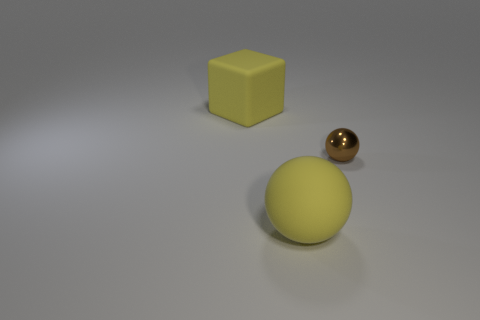Add 1 large brown cylinders. How many objects exist? 4 Subtract all brown spheres. How many spheres are left? 1 Subtract all spheres. How many objects are left? 1 Subtract all brown balls. Subtract all yellow cylinders. How many balls are left? 1 Subtract all yellow blocks. How many yellow balls are left? 1 Subtract all rubber objects. Subtract all small metallic balls. How many objects are left? 0 Add 2 big balls. How many big balls are left? 3 Add 3 tiny purple shiny cubes. How many tiny purple shiny cubes exist? 3 Subtract 0 purple cubes. How many objects are left? 3 